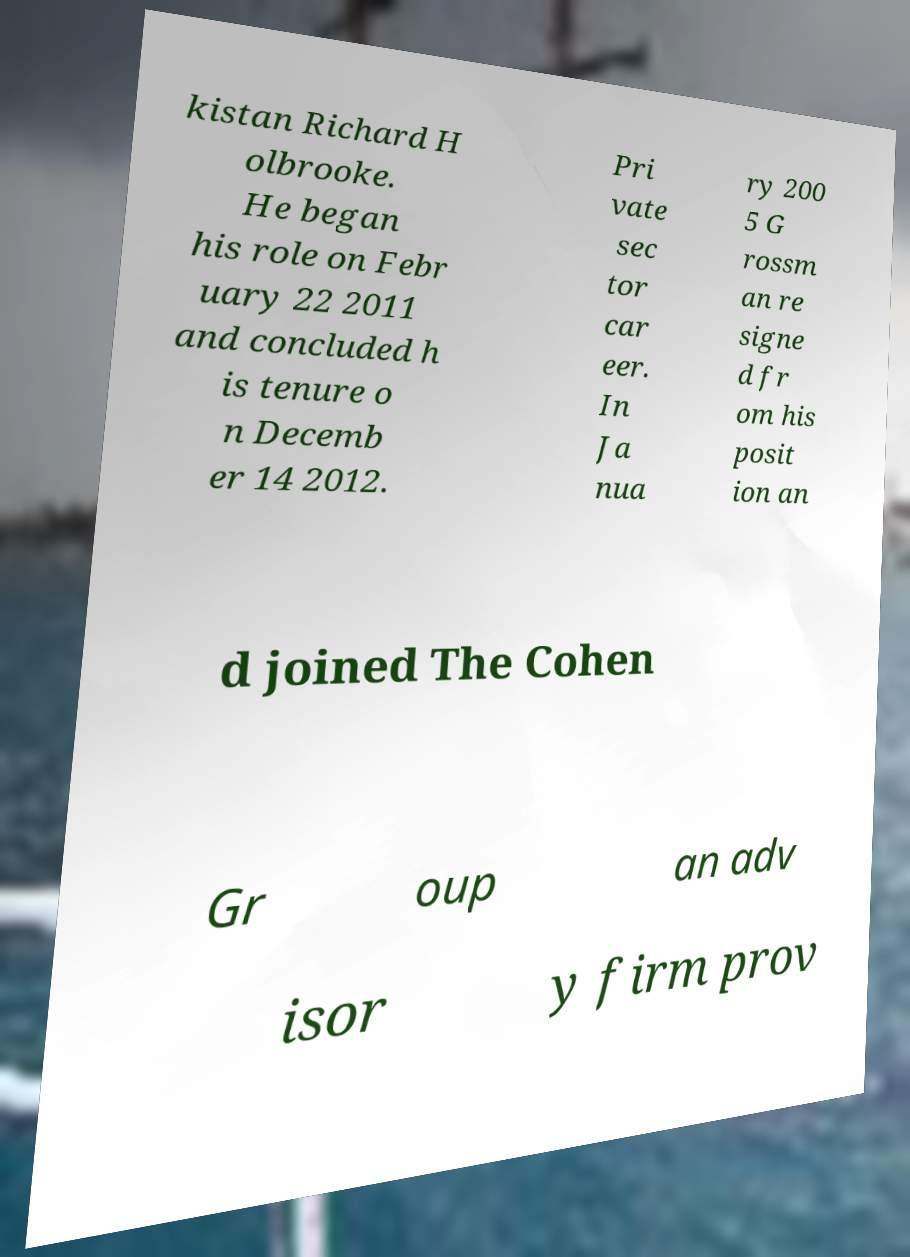Please read and relay the text visible in this image. What does it say? kistan Richard H olbrooke. He began his role on Febr uary 22 2011 and concluded h is tenure o n Decemb er 14 2012. Pri vate sec tor car eer. In Ja nua ry 200 5 G rossm an re signe d fr om his posit ion an d joined The Cohen Gr oup an adv isor y firm prov 